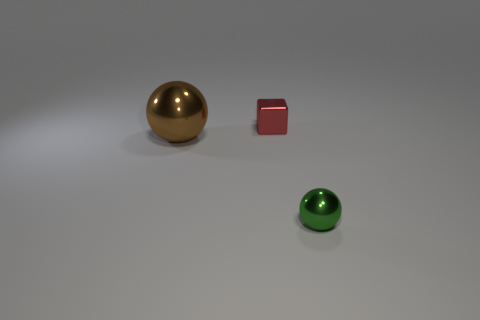Is there anything else that is the same size as the brown sphere?
Provide a short and direct response. No. How many things are either small things that are behind the large sphere or tiny things in front of the tiny red metal block?
Keep it short and to the point. 2. How many other things are the same shape as the brown shiny thing?
Ensure brevity in your answer.  1. There is a tiny object right of the red shiny cube; is it the same color as the cube?
Your response must be concise. No. How many other objects are the same size as the brown sphere?
Keep it short and to the point. 0. Is the material of the green ball the same as the red thing?
Offer a very short reply. Yes. There is a metallic sphere behind the sphere that is on the right side of the large shiny ball; what is its color?
Ensure brevity in your answer.  Brown. What size is the brown metallic thing that is the same shape as the green thing?
Offer a terse response. Large. Do the metal block and the big ball have the same color?
Make the answer very short. No. What number of green spheres are in front of the metallic object that is in front of the big brown metal ball in front of the red metallic object?
Your answer should be compact. 0. 